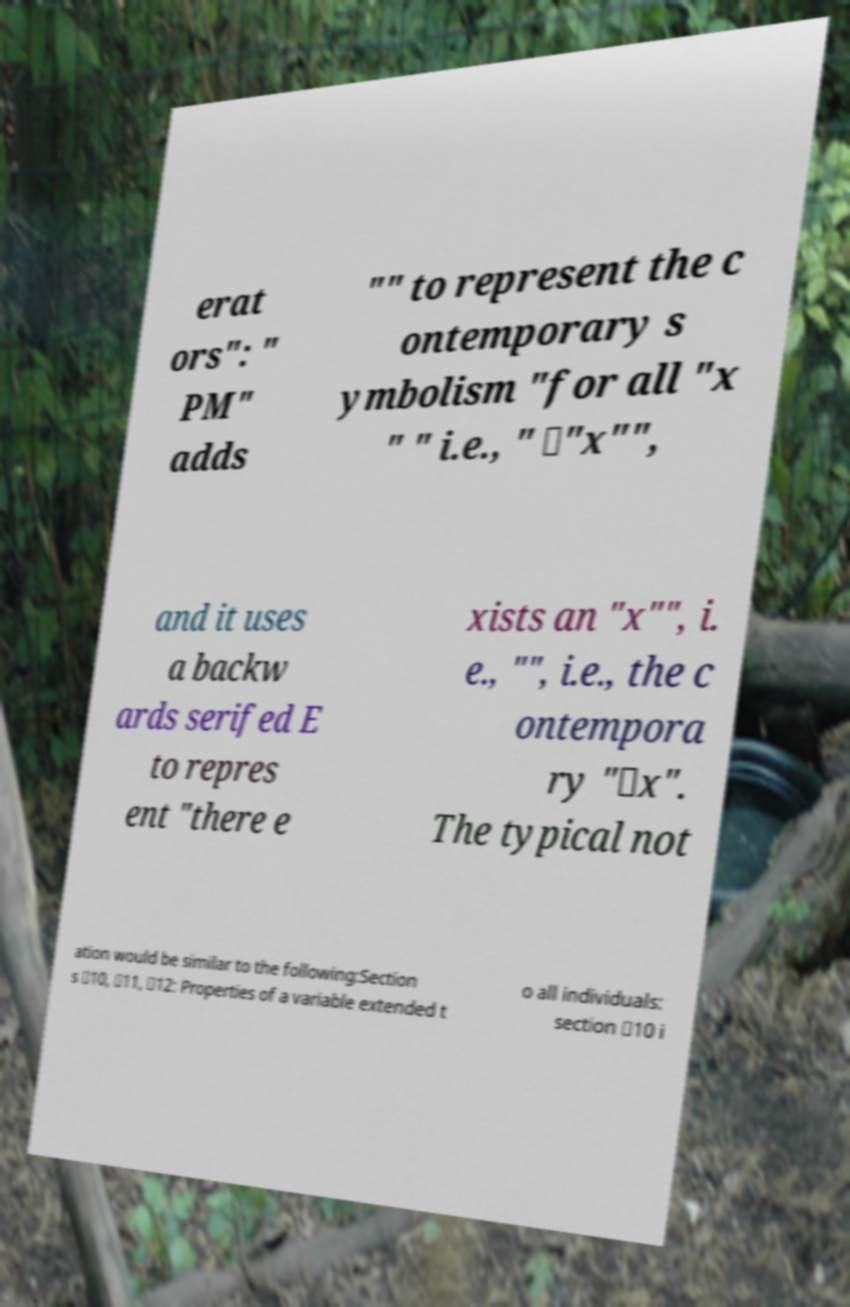Can you read and provide the text displayed in the image?This photo seems to have some interesting text. Can you extract and type it out for me? erat ors": " PM" adds "" to represent the c ontemporary s ymbolism "for all "x " " i.e., " ∀"x"", and it uses a backw ards serifed E to repres ent "there e xists an "x"", i. e., "", i.e., the c ontempora ry "∃x". The typical not ation would be similar to the following:Section s ✸10, ✸11, ✸12: Properties of a variable extended t o all individuals: section ✸10 i 